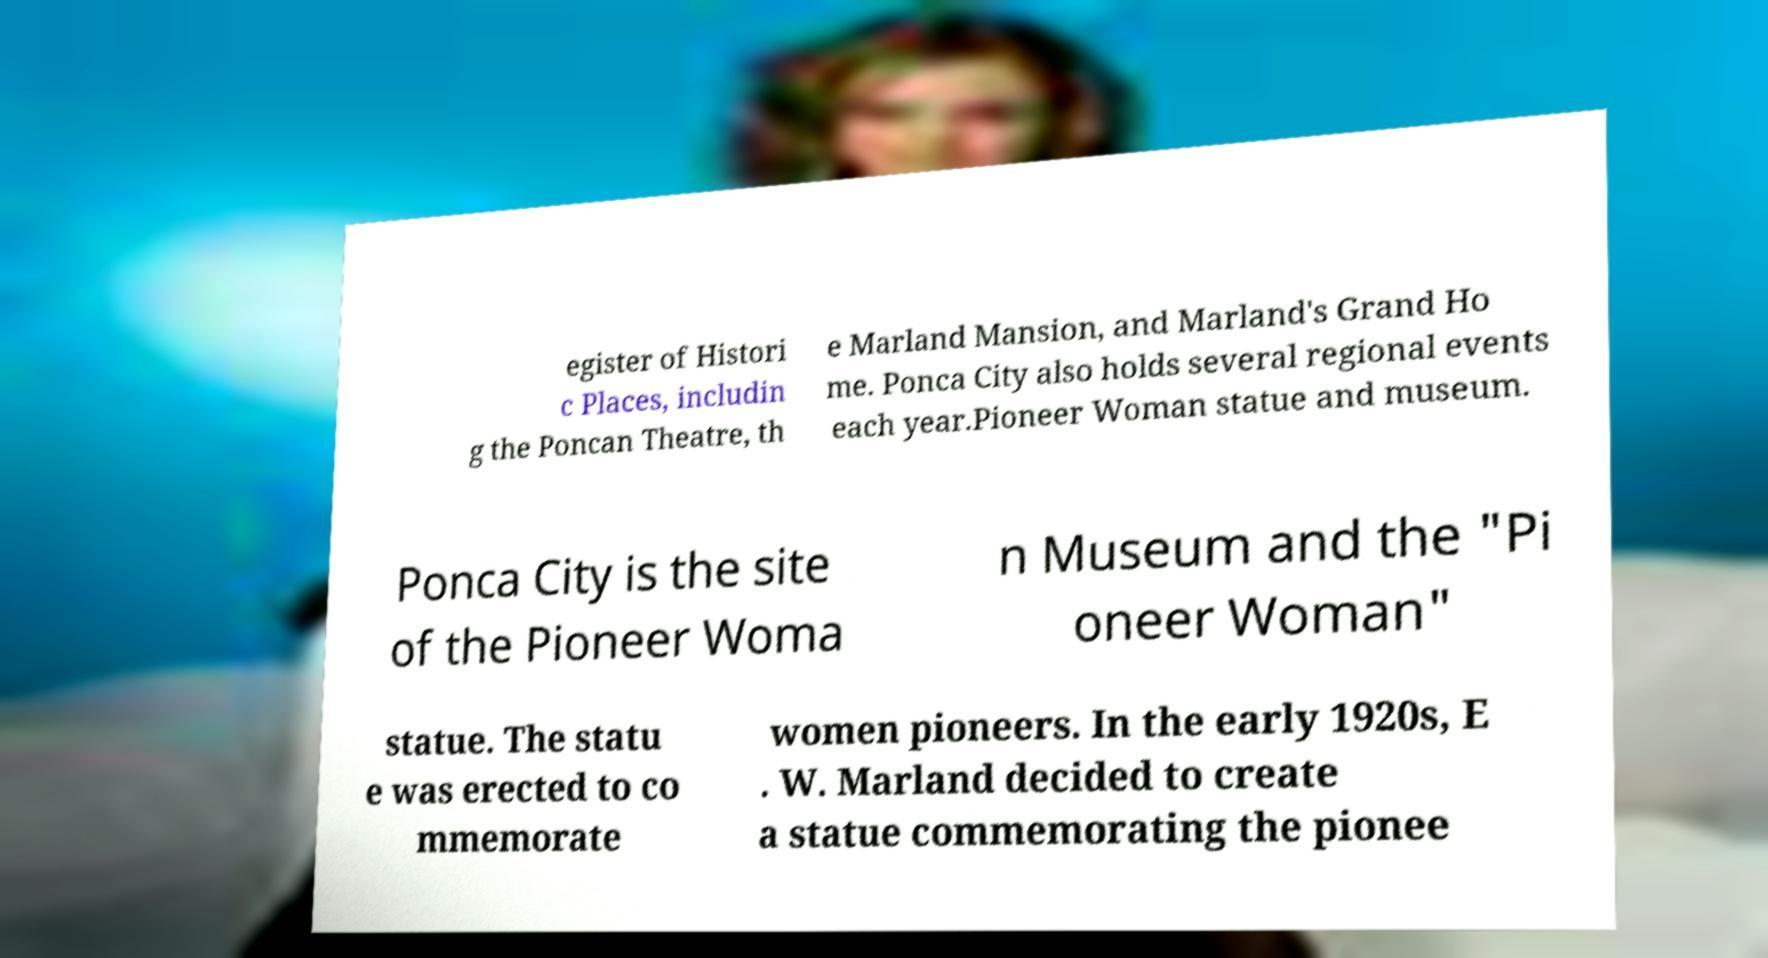What messages or text are displayed in this image? I need them in a readable, typed format. egister of Histori c Places, includin g the Poncan Theatre, th e Marland Mansion, and Marland's Grand Ho me. Ponca City also holds several regional events each year.Pioneer Woman statue and museum. Ponca City is the site of the Pioneer Woma n Museum and the "Pi oneer Woman" statue. The statu e was erected to co mmemorate women pioneers. In the early 1920s, E . W. Marland decided to create a statue commemorating the pionee 